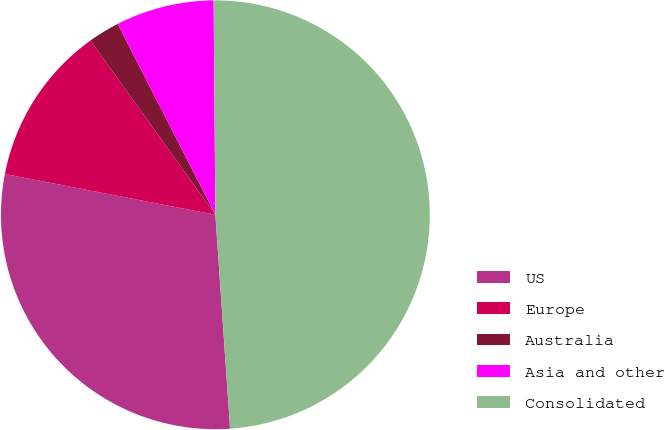<chart> <loc_0><loc_0><loc_500><loc_500><pie_chart><fcel>US<fcel>Europe<fcel>Australia<fcel>Asia and other<fcel>Consolidated<nl><fcel>29.14%<fcel>12.06%<fcel>2.37%<fcel>7.4%<fcel>49.04%<nl></chart> 